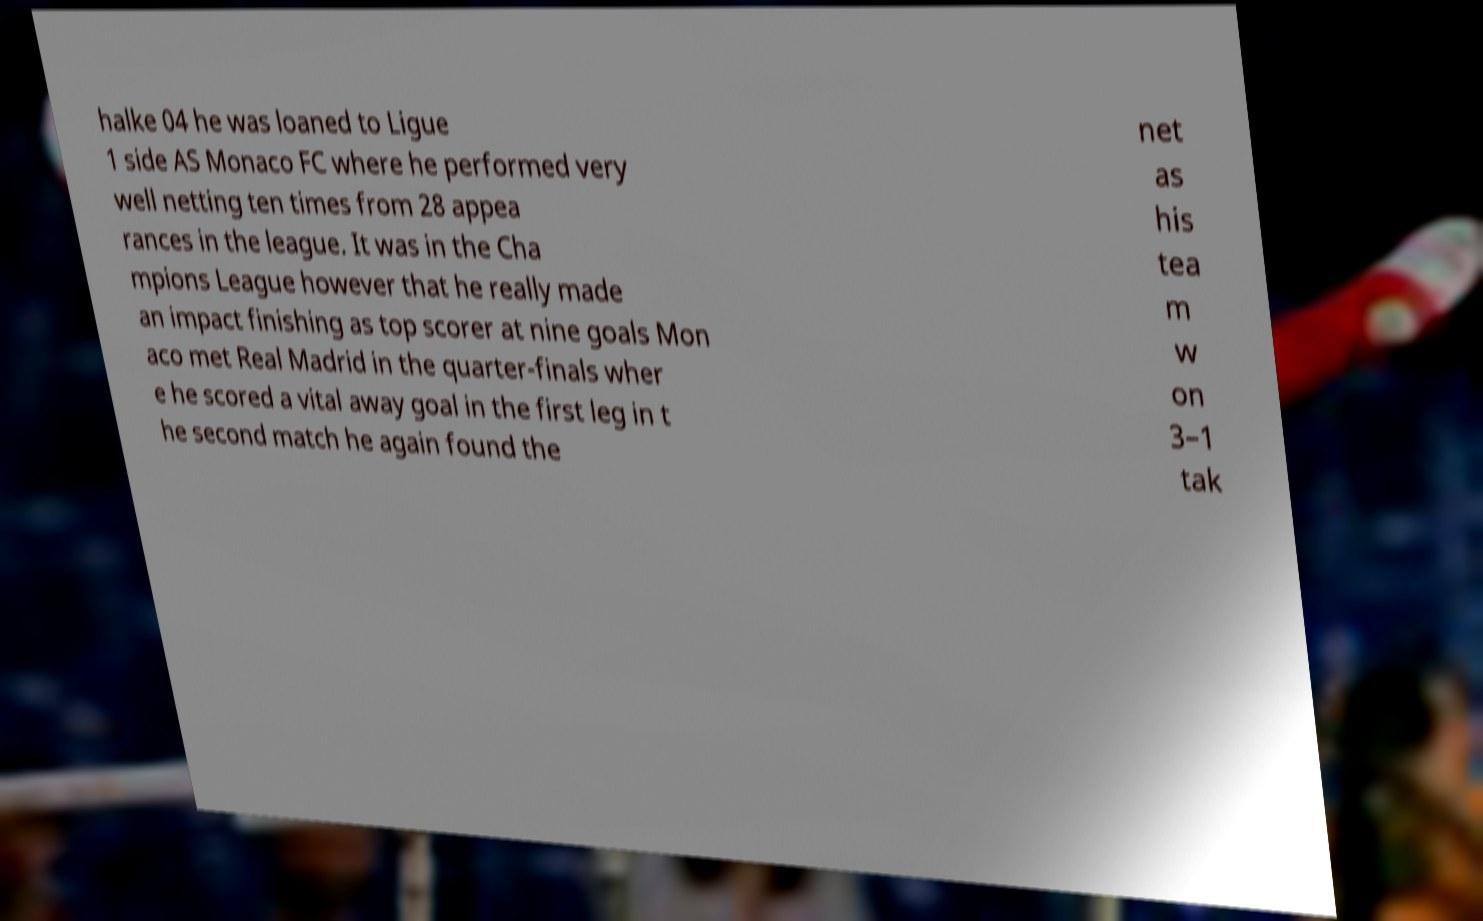Could you extract and type out the text from this image? halke 04 he was loaned to Ligue 1 side AS Monaco FC where he performed very well netting ten times from 28 appea rances in the league. It was in the Cha mpions League however that he really made an impact finishing as top scorer at nine goals Mon aco met Real Madrid in the quarter-finals wher e he scored a vital away goal in the first leg in t he second match he again found the net as his tea m w on 3–1 tak 